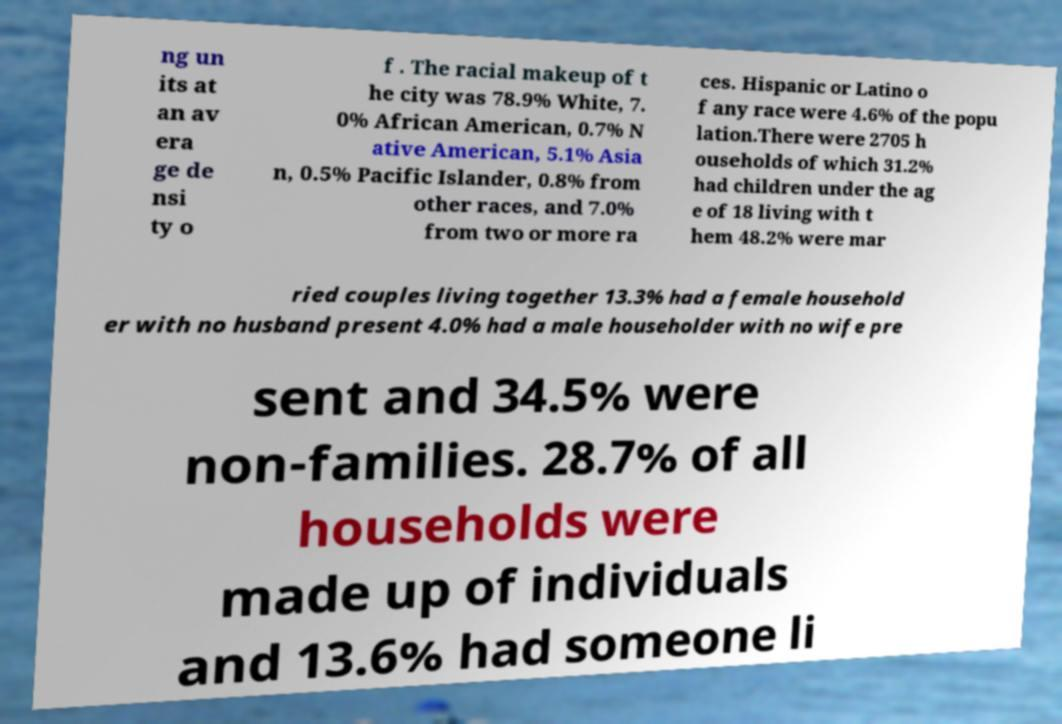Could you extract and type out the text from this image? ng un its at an av era ge de nsi ty o f . The racial makeup of t he city was 78.9% White, 7. 0% African American, 0.7% N ative American, 5.1% Asia n, 0.5% Pacific Islander, 0.8% from other races, and 7.0% from two or more ra ces. Hispanic or Latino o f any race were 4.6% of the popu lation.There were 2705 h ouseholds of which 31.2% had children under the ag e of 18 living with t hem 48.2% were mar ried couples living together 13.3% had a female household er with no husband present 4.0% had a male householder with no wife pre sent and 34.5% were non-families. 28.7% of all households were made up of individuals and 13.6% had someone li 